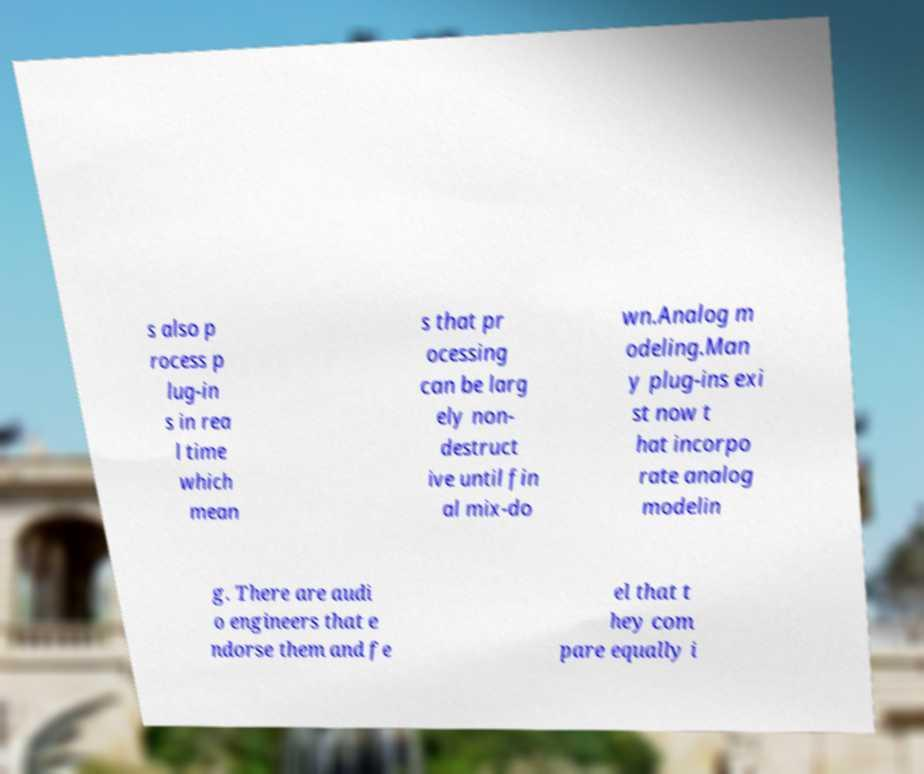Please read and relay the text visible in this image. What does it say? s also p rocess p lug-in s in rea l time which mean s that pr ocessing can be larg ely non- destruct ive until fin al mix-do wn.Analog m odeling.Man y plug-ins exi st now t hat incorpo rate analog modelin g. There are audi o engineers that e ndorse them and fe el that t hey com pare equally i 